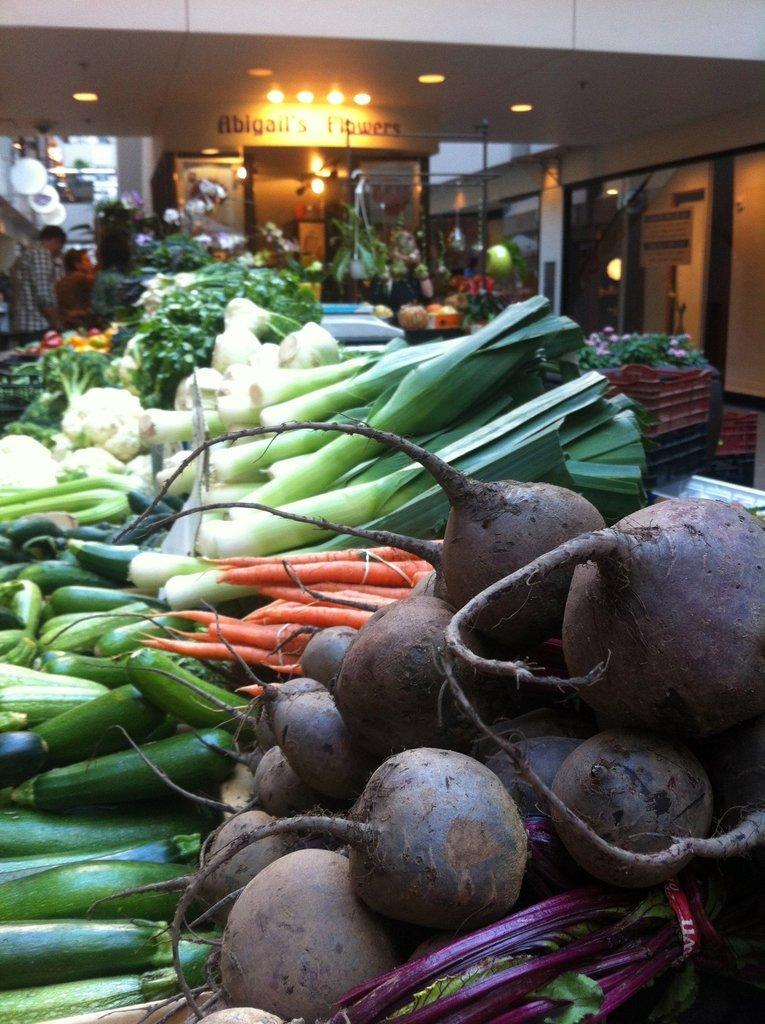How would you summarize this image in a sentence or two? In this image we can see many vegetables like turnips, cucumbers, carrots and many other vegetables. Also there is flowers on a plant. In the back there are many items. Also there are few people. On the ceiling there are lights. On the wall something is written. And there is a building. 